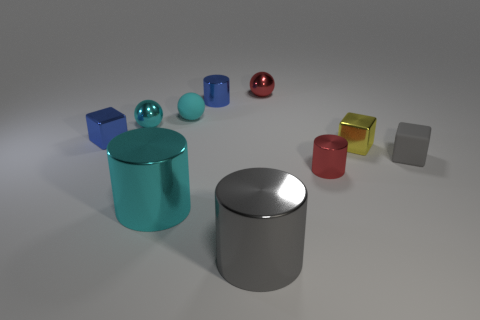Do the tiny rubber cube and the matte ball have the same color?
Give a very brief answer. No. How many things are in front of the big cyan metallic cylinder and behind the big cyan metallic thing?
Make the answer very short. 0. What number of matte balls are in front of the tiny red metal cylinder?
Ensure brevity in your answer.  0. Is there a small blue object that has the same shape as the small gray rubber object?
Your answer should be very brief. Yes. There is a yellow object; is its shape the same as the large shiny thing behind the gray cylinder?
Your response must be concise. No. What number of spheres are either yellow shiny objects or gray matte objects?
Give a very brief answer. 0. What is the shape of the small yellow metal thing behind the tiny rubber block?
Offer a very short reply. Cube. How many yellow cubes are made of the same material as the big gray thing?
Provide a succinct answer. 1. Is the number of cyan rubber balls on the right side of the small gray matte thing less than the number of shiny cylinders?
Make the answer very short. Yes. What is the size of the cyan shiny thing that is in front of the gray object behind the large gray cylinder?
Offer a very short reply. Large. 